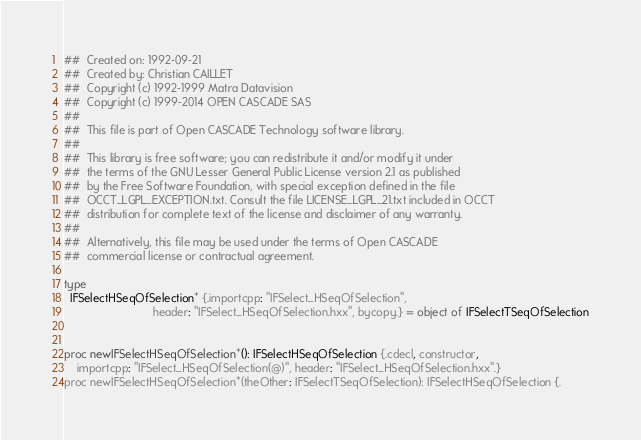Convert code to text. <code><loc_0><loc_0><loc_500><loc_500><_Nim_>##  Created on: 1992-09-21
##  Created by: Christian CAILLET
##  Copyright (c) 1992-1999 Matra Datavision
##  Copyright (c) 1999-2014 OPEN CASCADE SAS
##
##  This file is part of Open CASCADE Technology software library.
##
##  This library is free software; you can redistribute it and/or modify it under
##  the terms of the GNU Lesser General Public License version 2.1 as published
##  by the Free Software Foundation, with special exception defined in the file
##  OCCT_LGPL_EXCEPTION.txt. Consult the file LICENSE_LGPL_21.txt included in OCCT
##  distribution for complete text of the license and disclaimer of any warranty.
##
##  Alternatively, this file may be used under the terms of Open CASCADE
##  commercial license or contractual agreement.

type
  IFSelectHSeqOfSelection* {.importcpp: "IFSelect_HSeqOfSelection",
                            header: "IFSelect_HSeqOfSelection.hxx", bycopy.} = object of IFSelectTSeqOfSelection


proc newIFSelectHSeqOfSelection*(): IFSelectHSeqOfSelection {.cdecl, constructor,
    importcpp: "IFSelect_HSeqOfSelection(@)", header: "IFSelect_HSeqOfSelection.hxx".}
proc newIFSelectHSeqOfSelection*(theOther: IFSelectTSeqOfSelection): IFSelectHSeqOfSelection {.</code> 